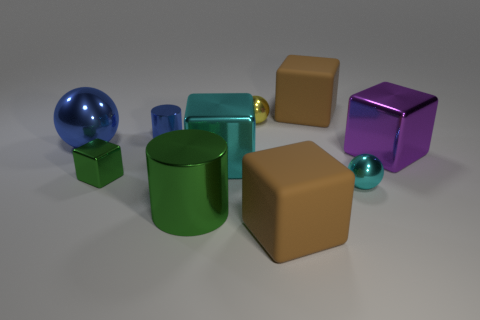Are there the same number of tiny things that are right of the purple metallic thing and large purple metal objects behind the blue shiny ball?
Your answer should be compact. Yes. What is the size of the metallic sphere right of the brown block in front of the big shiny cylinder?
Your response must be concise. Small. What is the material of the sphere that is behind the tiny cyan shiny ball and right of the big green metal thing?
Offer a very short reply. Metal. How many other things are there of the same size as the yellow object?
Provide a short and direct response. 3. The tiny shiny cube is what color?
Provide a short and direct response. Green. There is a big rubber block behind the large green metal cylinder; is its color the same as the matte object that is in front of the big cyan shiny block?
Give a very brief answer. Yes. The yellow object is what size?
Offer a terse response. Small. What size is the shiny sphere that is in front of the big purple shiny object?
Your response must be concise. Small. The big metal object that is both on the right side of the green cylinder and to the left of the purple object has what shape?
Your response must be concise. Cube. How many other things are there of the same shape as the large purple metal object?
Your answer should be compact. 4. 